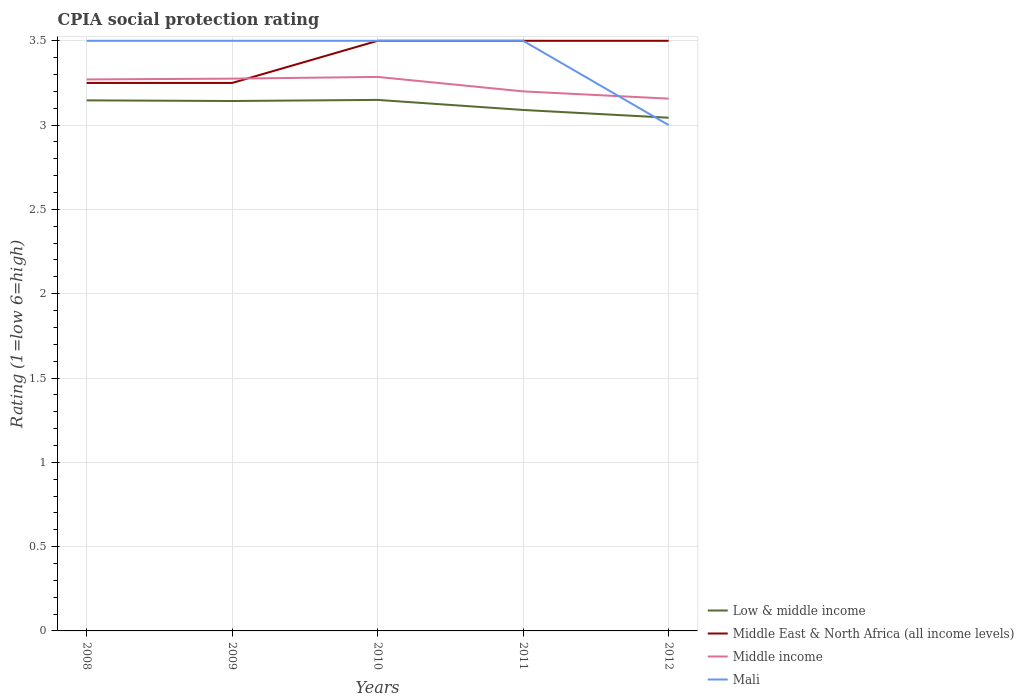Does the line corresponding to Mali intersect with the line corresponding to Middle income?
Offer a very short reply. Yes. Is the number of lines equal to the number of legend labels?
Your response must be concise. Yes. Across all years, what is the maximum CPIA rating in Middle income?
Make the answer very short. 3.16. What is the difference between the highest and the second highest CPIA rating in Middle East & North Africa (all income levels)?
Keep it short and to the point. 0.25. Is the CPIA rating in Mali strictly greater than the CPIA rating in Low & middle income over the years?
Keep it short and to the point. No. Are the values on the major ticks of Y-axis written in scientific E-notation?
Your answer should be compact. No. Does the graph contain any zero values?
Provide a short and direct response. No. Does the graph contain grids?
Your response must be concise. Yes. How many legend labels are there?
Make the answer very short. 4. What is the title of the graph?
Ensure brevity in your answer.  CPIA social protection rating. Does "West Bank and Gaza" appear as one of the legend labels in the graph?
Your answer should be compact. No. What is the Rating (1=low 6=high) of Low & middle income in 2008?
Your response must be concise. 3.15. What is the Rating (1=low 6=high) in Middle East & North Africa (all income levels) in 2008?
Provide a succinct answer. 3.25. What is the Rating (1=low 6=high) in Middle income in 2008?
Offer a very short reply. 3.27. What is the Rating (1=low 6=high) of Low & middle income in 2009?
Make the answer very short. 3.14. What is the Rating (1=low 6=high) in Middle income in 2009?
Your answer should be compact. 3.28. What is the Rating (1=low 6=high) of Low & middle income in 2010?
Provide a short and direct response. 3.15. What is the Rating (1=low 6=high) of Middle East & North Africa (all income levels) in 2010?
Your response must be concise. 3.5. What is the Rating (1=low 6=high) in Middle income in 2010?
Your answer should be compact. 3.29. What is the Rating (1=low 6=high) in Low & middle income in 2011?
Make the answer very short. 3.09. What is the Rating (1=low 6=high) in Middle income in 2011?
Ensure brevity in your answer.  3.2. What is the Rating (1=low 6=high) in Mali in 2011?
Offer a very short reply. 3.5. What is the Rating (1=low 6=high) of Low & middle income in 2012?
Give a very brief answer. 3.04. What is the Rating (1=low 6=high) of Middle East & North Africa (all income levels) in 2012?
Make the answer very short. 3.5. What is the Rating (1=low 6=high) in Middle income in 2012?
Make the answer very short. 3.16. What is the Rating (1=low 6=high) of Mali in 2012?
Ensure brevity in your answer.  3. Across all years, what is the maximum Rating (1=low 6=high) of Low & middle income?
Your answer should be very brief. 3.15. Across all years, what is the maximum Rating (1=low 6=high) of Middle East & North Africa (all income levels)?
Provide a succinct answer. 3.5. Across all years, what is the maximum Rating (1=low 6=high) in Middle income?
Your answer should be compact. 3.29. Across all years, what is the minimum Rating (1=low 6=high) of Low & middle income?
Give a very brief answer. 3.04. Across all years, what is the minimum Rating (1=low 6=high) of Middle income?
Your response must be concise. 3.16. Across all years, what is the minimum Rating (1=low 6=high) of Mali?
Your response must be concise. 3. What is the total Rating (1=low 6=high) of Low & middle income in the graph?
Offer a terse response. 15.57. What is the total Rating (1=low 6=high) of Middle East & North Africa (all income levels) in the graph?
Ensure brevity in your answer.  17. What is the total Rating (1=low 6=high) in Middle income in the graph?
Provide a succinct answer. 16.19. What is the difference between the Rating (1=low 6=high) in Low & middle income in 2008 and that in 2009?
Make the answer very short. 0. What is the difference between the Rating (1=low 6=high) in Middle income in 2008 and that in 2009?
Offer a terse response. -0. What is the difference between the Rating (1=low 6=high) in Mali in 2008 and that in 2009?
Your response must be concise. 0. What is the difference between the Rating (1=low 6=high) of Low & middle income in 2008 and that in 2010?
Your answer should be compact. -0. What is the difference between the Rating (1=low 6=high) of Middle East & North Africa (all income levels) in 2008 and that in 2010?
Give a very brief answer. -0.25. What is the difference between the Rating (1=low 6=high) in Middle income in 2008 and that in 2010?
Your answer should be very brief. -0.01. What is the difference between the Rating (1=low 6=high) in Low & middle income in 2008 and that in 2011?
Offer a very short reply. 0.06. What is the difference between the Rating (1=low 6=high) of Middle income in 2008 and that in 2011?
Offer a terse response. 0.07. What is the difference between the Rating (1=low 6=high) in Mali in 2008 and that in 2011?
Make the answer very short. 0. What is the difference between the Rating (1=low 6=high) in Low & middle income in 2008 and that in 2012?
Your answer should be compact. 0.1. What is the difference between the Rating (1=low 6=high) of Middle East & North Africa (all income levels) in 2008 and that in 2012?
Provide a short and direct response. -0.25. What is the difference between the Rating (1=low 6=high) in Middle income in 2008 and that in 2012?
Your answer should be very brief. 0.11. What is the difference between the Rating (1=low 6=high) in Mali in 2008 and that in 2012?
Ensure brevity in your answer.  0.5. What is the difference between the Rating (1=low 6=high) in Low & middle income in 2009 and that in 2010?
Your answer should be compact. -0.01. What is the difference between the Rating (1=low 6=high) in Middle East & North Africa (all income levels) in 2009 and that in 2010?
Provide a succinct answer. -0.25. What is the difference between the Rating (1=low 6=high) in Middle income in 2009 and that in 2010?
Your answer should be compact. -0.01. What is the difference between the Rating (1=low 6=high) in Mali in 2009 and that in 2010?
Ensure brevity in your answer.  0. What is the difference between the Rating (1=low 6=high) in Low & middle income in 2009 and that in 2011?
Provide a short and direct response. 0.05. What is the difference between the Rating (1=low 6=high) of Middle East & North Africa (all income levels) in 2009 and that in 2011?
Ensure brevity in your answer.  -0.25. What is the difference between the Rating (1=low 6=high) in Middle income in 2009 and that in 2011?
Give a very brief answer. 0.08. What is the difference between the Rating (1=low 6=high) of Mali in 2009 and that in 2011?
Keep it short and to the point. 0. What is the difference between the Rating (1=low 6=high) of Low & middle income in 2009 and that in 2012?
Keep it short and to the point. 0.1. What is the difference between the Rating (1=low 6=high) in Middle income in 2009 and that in 2012?
Your answer should be compact. 0.12. What is the difference between the Rating (1=low 6=high) in Low & middle income in 2010 and that in 2011?
Offer a terse response. 0.06. What is the difference between the Rating (1=low 6=high) of Middle income in 2010 and that in 2011?
Offer a terse response. 0.09. What is the difference between the Rating (1=low 6=high) in Mali in 2010 and that in 2011?
Provide a succinct answer. 0. What is the difference between the Rating (1=low 6=high) in Low & middle income in 2010 and that in 2012?
Your response must be concise. 0.11. What is the difference between the Rating (1=low 6=high) of Middle East & North Africa (all income levels) in 2010 and that in 2012?
Make the answer very short. 0. What is the difference between the Rating (1=low 6=high) of Middle income in 2010 and that in 2012?
Provide a succinct answer. 0.13. What is the difference between the Rating (1=low 6=high) in Mali in 2010 and that in 2012?
Ensure brevity in your answer.  0.5. What is the difference between the Rating (1=low 6=high) of Low & middle income in 2011 and that in 2012?
Make the answer very short. 0.05. What is the difference between the Rating (1=low 6=high) of Middle income in 2011 and that in 2012?
Offer a terse response. 0.04. What is the difference between the Rating (1=low 6=high) of Mali in 2011 and that in 2012?
Provide a short and direct response. 0.5. What is the difference between the Rating (1=low 6=high) of Low & middle income in 2008 and the Rating (1=low 6=high) of Middle East & North Africa (all income levels) in 2009?
Provide a short and direct response. -0.1. What is the difference between the Rating (1=low 6=high) of Low & middle income in 2008 and the Rating (1=low 6=high) of Middle income in 2009?
Provide a short and direct response. -0.13. What is the difference between the Rating (1=low 6=high) of Low & middle income in 2008 and the Rating (1=low 6=high) of Mali in 2009?
Provide a succinct answer. -0.35. What is the difference between the Rating (1=low 6=high) of Middle East & North Africa (all income levels) in 2008 and the Rating (1=low 6=high) of Middle income in 2009?
Offer a terse response. -0.03. What is the difference between the Rating (1=low 6=high) of Middle East & North Africa (all income levels) in 2008 and the Rating (1=low 6=high) of Mali in 2009?
Your response must be concise. -0.25. What is the difference between the Rating (1=low 6=high) of Middle income in 2008 and the Rating (1=low 6=high) of Mali in 2009?
Offer a very short reply. -0.23. What is the difference between the Rating (1=low 6=high) of Low & middle income in 2008 and the Rating (1=low 6=high) of Middle East & North Africa (all income levels) in 2010?
Make the answer very short. -0.35. What is the difference between the Rating (1=low 6=high) of Low & middle income in 2008 and the Rating (1=low 6=high) of Middle income in 2010?
Make the answer very short. -0.14. What is the difference between the Rating (1=low 6=high) in Low & middle income in 2008 and the Rating (1=low 6=high) in Mali in 2010?
Your response must be concise. -0.35. What is the difference between the Rating (1=low 6=high) in Middle East & North Africa (all income levels) in 2008 and the Rating (1=low 6=high) in Middle income in 2010?
Provide a succinct answer. -0.04. What is the difference between the Rating (1=low 6=high) of Middle East & North Africa (all income levels) in 2008 and the Rating (1=low 6=high) of Mali in 2010?
Provide a succinct answer. -0.25. What is the difference between the Rating (1=low 6=high) of Middle income in 2008 and the Rating (1=low 6=high) of Mali in 2010?
Your answer should be very brief. -0.23. What is the difference between the Rating (1=low 6=high) in Low & middle income in 2008 and the Rating (1=low 6=high) in Middle East & North Africa (all income levels) in 2011?
Your answer should be compact. -0.35. What is the difference between the Rating (1=low 6=high) in Low & middle income in 2008 and the Rating (1=low 6=high) in Middle income in 2011?
Keep it short and to the point. -0.05. What is the difference between the Rating (1=low 6=high) of Low & middle income in 2008 and the Rating (1=low 6=high) of Mali in 2011?
Make the answer very short. -0.35. What is the difference between the Rating (1=low 6=high) in Middle East & North Africa (all income levels) in 2008 and the Rating (1=low 6=high) in Middle income in 2011?
Your response must be concise. 0.05. What is the difference between the Rating (1=low 6=high) in Middle income in 2008 and the Rating (1=low 6=high) in Mali in 2011?
Make the answer very short. -0.23. What is the difference between the Rating (1=low 6=high) in Low & middle income in 2008 and the Rating (1=low 6=high) in Middle East & North Africa (all income levels) in 2012?
Give a very brief answer. -0.35. What is the difference between the Rating (1=low 6=high) of Low & middle income in 2008 and the Rating (1=low 6=high) of Middle income in 2012?
Provide a succinct answer. -0.01. What is the difference between the Rating (1=low 6=high) of Low & middle income in 2008 and the Rating (1=low 6=high) of Mali in 2012?
Your response must be concise. 0.15. What is the difference between the Rating (1=low 6=high) of Middle East & North Africa (all income levels) in 2008 and the Rating (1=low 6=high) of Middle income in 2012?
Provide a short and direct response. 0.09. What is the difference between the Rating (1=low 6=high) in Middle income in 2008 and the Rating (1=low 6=high) in Mali in 2012?
Offer a terse response. 0.27. What is the difference between the Rating (1=low 6=high) of Low & middle income in 2009 and the Rating (1=low 6=high) of Middle East & North Africa (all income levels) in 2010?
Give a very brief answer. -0.36. What is the difference between the Rating (1=low 6=high) of Low & middle income in 2009 and the Rating (1=low 6=high) of Middle income in 2010?
Your response must be concise. -0.14. What is the difference between the Rating (1=low 6=high) of Low & middle income in 2009 and the Rating (1=low 6=high) of Mali in 2010?
Your answer should be compact. -0.36. What is the difference between the Rating (1=low 6=high) of Middle East & North Africa (all income levels) in 2009 and the Rating (1=low 6=high) of Middle income in 2010?
Offer a very short reply. -0.04. What is the difference between the Rating (1=low 6=high) of Middle East & North Africa (all income levels) in 2009 and the Rating (1=low 6=high) of Mali in 2010?
Your answer should be compact. -0.25. What is the difference between the Rating (1=low 6=high) in Middle income in 2009 and the Rating (1=low 6=high) in Mali in 2010?
Make the answer very short. -0.22. What is the difference between the Rating (1=low 6=high) in Low & middle income in 2009 and the Rating (1=low 6=high) in Middle East & North Africa (all income levels) in 2011?
Your answer should be compact. -0.36. What is the difference between the Rating (1=low 6=high) of Low & middle income in 2009 and the Rating (1=low 6=high) of Middle income in 2011?
Your response must be concise. -0.06. What is the difference between the Rating (1=low 6=high) in Low & middle income in 2009 and the Rating (1=low 6=high) in Mali in 2011?
Your answer should be compact. -0.36. What is the difference between the Rating (1=low 6=high) in Middle East & North Africa (all income levels) in 2009 and the Rating (1=low 6=high) in Middle income in 2011?
Make the answer very short. 0.05. What is the difference between the Rating (1=low 6=high) of Middle income in 2009 and the Rating (1=low 6=high) of Mali in 2011?
Offer a terse response. -0.22. What is the difference between the Rating (1=low 6=high) of Low & middle income in 2009 and the Rating (1=low 6=high) of Middle East & North Africa (all income levels) in 2012?
Your answer should be compact. -0.36. What is the difference between the Rating (1=low 6=high) in Low & middle income in 2009 and the Rating (1=low 6=high) in Middle income in 2012?
Ensure brevity in your answer.  -0.01. What is the difference between the Rating (1=low 6=high) in Low & middle income in 2009 and the Rating (1=low 6=high) in Mali in 2012?
Your answer should be very brief. 0.14. What is the difference between the Rating (1=low 6=high) in Middle East & North Africa (all income levels) in 2009 and the Rating (1=low 6=high) in Middle income in 2012?
Provide a succinct answer. 0.09. What is the difference between the Rating (1=low 6=high) in Middle East & North Africa (all income levels) in 2009 and the Rating (1=low 6=high) in Mali in 2012?
Make the answer very short. 0.25. What is the difference between the Rating (1=low 6=high) of Middle income in 2009 and the Rating (1=low 6=high) of Mali in 2012?
Your answer should be very brief. 0.28. What is the difference between the Rating (1=low 6=high) of Low & middle income in 2010 and the Rating (1=low 6=high) of Middle East & North Africa (all income levels) in 2011?
Ensure brevity in your answer.  -0.35. What is the difference between the Rating (1=low 6=high) in Low & middle income in 2010 and the Rating (1=low 6=high) in Middle income in 2011?
Keep it short and to the point. -0.05. What is the difference between the Rating (1=low 6=high) in Low & middle income in 2010 and the Rating (1=low 6=high) in Mali in 2011?
Provide a short and direct response. -0.35. What is the difference between the Rating (1=low 6=high) in Middle East & North Africa (all income levels) in 2010 and the Rating (1=low 6=high) in Middle income in 2011?
Keep it short and to the point. 0.3. What is the difference between the Rating (1=low 6=high) in Middle income in 2010 and the Rating (1=low 6=high) in Mali in 2011?
Provide a short and direct response. -0.21. What is the difference between the Rating (1=low 6=high) in Low & middle income in 2010 and the Rating (1=low 6=high) in Middle East & North Africa (all income levels) in 2012?
Your answer should be compact. -0.35. What is the difference between the Rating (1=low 6=high) in Low & middle income in 2010 and the Rating (1=low 6=high) in Middle income in 2012?
Give a very brief answer. -0.01. What is the difference between the Rating (1=low 6=high) in Low & middle income in 2010 and the Rating (1=low 6=high) in Mali in 2012?
Give a very brief answer. 0.15. What is the difference between the Rating (1=low 6=high) of Middle East & North Africa (all income levels) in 2010 and the Rating (1=low 6=high) of Middle income in 2012?
Your response must be concise. 0.34. What is the difference between the Rating (1=low 6=high) of Middle income in 2010 and the Rating (1=low 6=high) of Mali in 2012?
Provide a succinct answer. 0.29. What is the difference between the Rating (1=low 6=high) of Low & middle income in 2011 and the Rating (1=low 6=high) of Middle East & North Africa (all income levels) in 2012?
Your answer should be compact. -0.41. What is the difference between the Rating (1=low 6=high) of Low & middle income in 2011 and the Rating (1=low 6=high) of Middle income in 2012?
Ensure brevity in your answer.  -0.07. What is the difference between the Rating (1=low 6=high) of Low & middle income in 2011 and the Rating (1=low 6=high) of Mali in 2012?
Offer a terse response. 0.09. What is the difference between the Rating (1=low 6=high) of Middle East & North Africa (all income levels) in 2011 and the Rating (1=low 6=high) of Middle income in 2012?
Keep it short and to the point. 0.34. What is the difference between the Rating (1=low 6=high) of Middle income in 2011 and the Rating (1=low 6=high) of Mali in 2012?
Your answer should be very brief. 0.2. What is the average Rating (1=low 6=high) in Low & middle income per year?
Make the answer very short. 3.11. What is the average Rating (1=low 6=high) in Middle East & North Africa (all income levels) per year?
Your answer should be very brief. 3.4. What is the average Rating (1=low 6=high) in Middle income per year?
Provide a short and direct response. 3.24. In the year 2008, what is the difference between the Rating (1=low 6=high) of Low & middle income and Rating (1=low 6=high) of Middle East & North Africa (all income levels)?
Ensure brevity in your answer.  -0.1. In the year 2008, what is the difference between the Rating (1=low 6=high) in Low & middle income and Rating (1=low 6=high) in Middle income?
Your answer should be compact. -0.12. In the year 2008, what is the difference between the Rating (1=low 6=high) of Low & middle income and Rating (1=low 6=high) of Mali?
Ensure brevity in your answer.  -0.35. In the year 2008, what is the difference between the Rating (1=low 6=high) in Middle East & North Africa (all income levels) and Rating (1=low 6=high) in Middle income?
Give a very brief answer. -0.02. In the year 2008, what is the difference between the Rating (1=low 6=high) of Middle East & North Africa (all income levels) and Rating (1=low 6=high) of Mali?
Offer a terse response. -0.25. In the year 2008, what is the difference between the Rating (1=low 6=high) of Middle income and Rating (1=low 6=high) of Mali?
Make the answer very short. -0.23. In the year 2009, what is the difference between the Rating (1=low 6=high) in Low & middle income and Rating (1=low 6=high) in Middle East & North Africa (all income levels)?
Make the answer very short. -0.11. In the year 2009, what is the difference between the Rating (1=low 6=high) in Low & middle income and Rating (1=low 6=high) in Middle income?
Ensure brevity in your answer.  -0.13. In the year 2009, what is the difference between the Rating (1=low 6=high) in Low & middle income and Rating (1=low 6=high) in Mali?
Offer a very short reply. -0.36. In the year 2009, what is the difference between the Rating (1=low 6=high) of Middle East & North Africa (all income levels) and Rating (1=low 6=high) of Middle income?
Keep it short and to the point. -0.03. In the year 2009, what is the difference between the Rating (1=low 6=high) in Middle East & North Africa (all income levels) and Rating (1=low 6=high) in Mali?
Make the answer very short. -0.25. In the year 2009, what is the difference between the Rating (1=low 6=high) of Middle income and Rating (1=low 6=high) of Mali?
Offer a terse response. -0.22. In the year 2010, what is the difference between the Rating (1=low 6=high) in Low & middle income and Rating (1=low 6=high) in Middle East & North Africa (all income levels)?
Provide a short and direct response. -0.35. In the year 2010, what is the difference between the Rating (1=low 6=high) in Low & middle income and Rating (1=low 6=high) in Middle income?
Ensure brevity in your answer.  -0.14. In the year 2010, what is the difference between the Rating (1=low 6=high) in Low & middle income and Rating (1=low 6=high) in Mali?
Offer a very short reply. -0.35. In the year 2010, what is the difference between the Rating (1=low 6=high) of Middle East & North Africa (all income levels) and Rating (1=low 6=high) of Middle income?
Your answer should be very brief. 0.21. In the year 2010, what is the difference between the Rating (1=low 6=high) of Middle East & North Africa (all income levels) and Rating (1=low 6=high) of Mali?
Ensure brevity in your answer.  0. In the year 2010, what is the difference between the Rating (1=low 6=high) in Middle income and Rating (1=low 6=high) in Mali?
Your answer should be compact. -0.21. In the year 2011, what is the difference between the Rating (1=low 6=high) of Low & middle income and Rating (1=low 6=high) of Middle East & North Africa (all income levels)?
Ensure brevity in your answer.  -0.41. In the year 2011, what is the difference between the Rating (1=low 6=high) in Low & middle income and Rating (1=low 6=high) in Middle income?
Give a very brief answer. -0.11. In the year 2011, what is the difference between the Rating (1=low 6=high) in Low & middle income and Rating (1=low 6=high) in Mali?
Make the answer very short. -0.41. In the year 2012, what is the difference between the Rating (1=low 6=high) of Low & middle income and Rating (1=low 6=high) of Middle East & North Africa (all income levels)?
Make the answer very short. -0.46. In the year 2012, what is the difference between the Rating (1=low 6=high) of Low & middle income and Rating (1=low 6=high) of Middle income?
Provide a succinct answer. -0.11. In the year 2012, what is the difference between the Rating (1=low 6=high) in Low & middle income and Rating (1=low 6=high) in Mali?
Provide a succinct answer. 0.04. In the year 2012, what is the difference between the Rating (1=low 6=high) in Middle East & North Africa (all income levels) and Rating (1=low 6=high) in Middle income?
Give a very brief answer. 0.34. In the year 2012, what is the difference between the Rating (1=low 6=high) of Middle income and Rating (1=low 6=high) of Mali?
Give a very brief answer. 0.16. What is the ratio of the Rating (1=low 6=high) of Middle East & North Africa (all income levels) in 2008 to that in 2009?
Make the answer very short. 1. What is the ratio of the Rating (1=low 6=high) of Low & middle income in 2008 to that in 2010?
Your answer should be very brief. 1. What is the ratio of the Rating (1=low 6=high) in Middle income in 2008 to that in 2010?
Offer a terse response. 1. What is the ratio of the Rating (1=low 6=high) in Low & middle income in 2008 to that in 2011?
Your answer should be very brief. 1.02. What is the ratio of the Rating (1=low 6=high) in Middle income in 2008 to that in 2011?
Offer a terse response. 1.02. What is the ratio of the Rating (1=low 6=high) of Mali in 2008 to that in 2011?
Provide a short and direct response. 1. What is the ratio of the Rating (1=low 6=high) of Low & middle income in 2008 to that in 2012?
Provide a short and direct response. 1.03. What is the ratio of the Rating (1=low 6=high) in Middle East & North Africa (all income levels) in 2008 to that in 2012?
Provide a succinct answer. 0.93. What is the ratio of the Rating (1=low 6=high) in Middle income in 2008 to that in 2012?
Make the answer very short. 1.04. What is the ratio of the Rating (1=low 6=high) of Mali in 2008 to that in 2012?
Your response must be concise. 1.17. What is the ratio of the Rating (1=low 6=high) of Middle income in 2009 to that in 2010?
Provide a short and direct response. 1. What is the ratio of the Rating (1=low 6=high) in Mali in 2009 to that in 2010?
Keep it short and to the point. 1. What is the ratio of the Rating (1=low 6=high) in Low & middle income in 2009 to that in 2011?
Provide a succinct answer. 1.02. What is the ratio of the Rating (1=low 6=high) in Middle East & North Africa (all income levels) in 2009 to that in 2011?
Provide a succinct answer. 0.93. What is the ratio of the Rating (1=low 6=high) in Middle income in 2009 to that in 2011?
Your answer should be very brief. 1.02. What is the ratio of the Rating (1=low 6=high) of Low & middle income in 2009 to that in 2012?
Ensure brevity in your answer.  1.03. What is the ratio of the Rating (1=low 6=high) in Middle East & North Africa (all income levels) in 2009 to that in 2012?
Your answer should be very brief. 0.93. What is the ratio of the Rating (1=low 6=high) in Middle income in 2009 to that in 2012?
Make the answer very short. 1.04. What is the ratio of the Rating (1=low 6=high) of Mali in 2009 to that in 2012?
Offer a terse response. 1.17. What is the ratio of the Rating (1=low 6=high) of Low & middle income in 2010 to that in 2011?
Ensure brevity in your answer.  1.02. What is the ratio of the Rating (1=low 6=high) in Middle East & North Africa (all income levels) in 2010 to that in 2011?
Give a very brief answer. 1. What is the ratio of the Rating (1=low 6=high) in Middle income in 2010 to that in 2011?
Keep it short and to the point. 1.03. What is the ratio of the Rating (1=low 6=high) in Mali in 2010 to that in 2011?
Offer a terse response. 1. What is the ratio of the Rating (1=low 6=high) in Low & middle income in 2010 to that in 2012?
Give a very brief answer. 1.03. What is the ratio of the Rating (1=low 6=high) in Middle income in 2010 to that in 2012?
Keep it short and to the point. 1.04. What is the ratio of the Rating (1=low 6=high) in Low & middle income in 2011 to that in 2012?
Your answer should be compact. 1.02. What is the ratio of the Rating (1=low 6=high) of Middle East & North Africa (all income levels) in 2011 to that in 2012?
Give a very brief answer. 1. What is the ratio of the Rating (1=low 6=high) of Middle income in 2011 to that in 2012?
Offer a very short reply. 1.01. What is the ratio of the Rating (1=low 6=high) in Mali in 2011 to that in 2012?
Your answer should be very brief. 1.17. What is the difference between the highest and the second highest Rating (1=low 6=high) in Low & middle income?
Keep it short and to the point. 0. What is the difference between the highest and the second highest Rating (1=low 6=high) of Middle income?
Give a very brief answer. 0.01. What is the difference between the highest and the second highest Rating (1=low 6=high) of Mali?
Your response must be concise. 0. What is the difference between the highest and the lowest Rating (1=low 6=high) in Low & middle income?
Offer a very short reply. 0.11. What is the difference between the highest and the lowest Rating (1=low 6=high) in Middle income?
Provide a succinct answer. 0.13. 